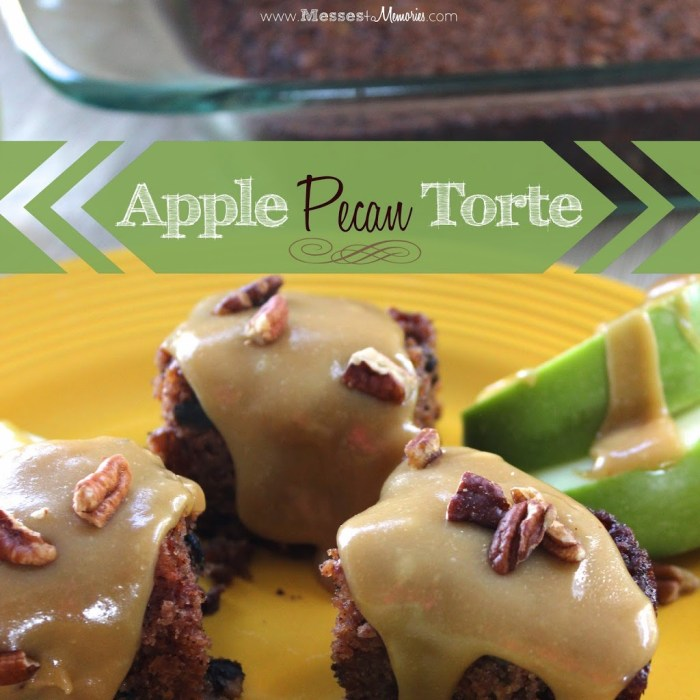What technique might have been used to achieve the moist texture of the apple pecan torte? The moist texture of the apple pecan torte in the image could likely be achieved through the incorporation of finely chopped or grated apples in the batter. Apples not only imbue the cake with their inherent moisture but also release it during the baking process, helping to keep the cake tender. Additionally, using ingredients that retain moisture such as brown sugar, oil, or even yogurt might have been employed to help maintain this desired texture. Are there any specific spices that would enhance the flavor of such a dessert? Certainly! Spices like cinnamon, nutmeg, and ginger would enhance the flavor of an apple pecan torte by complementing the natural sweetness of the apples and the nutty flavor of the pecans. These spices round out the flavors and add warmth and depth, making the dessert even more inviting and aromatic. 